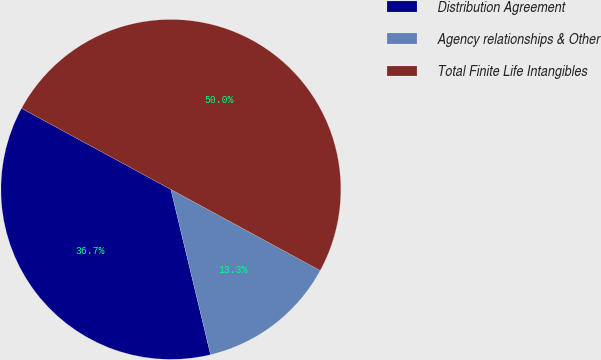Convert chart. <chart><loc_0><loc_0><loc_500><loc_500><pie_chart><fcel>Distribution Agreement<fcel>Agency relationships & Other<fcel>Total Finite Life Intangibles<nl><fcel>36.67%<fcel>13.33%<fcel>50.0%<nl></chart> 